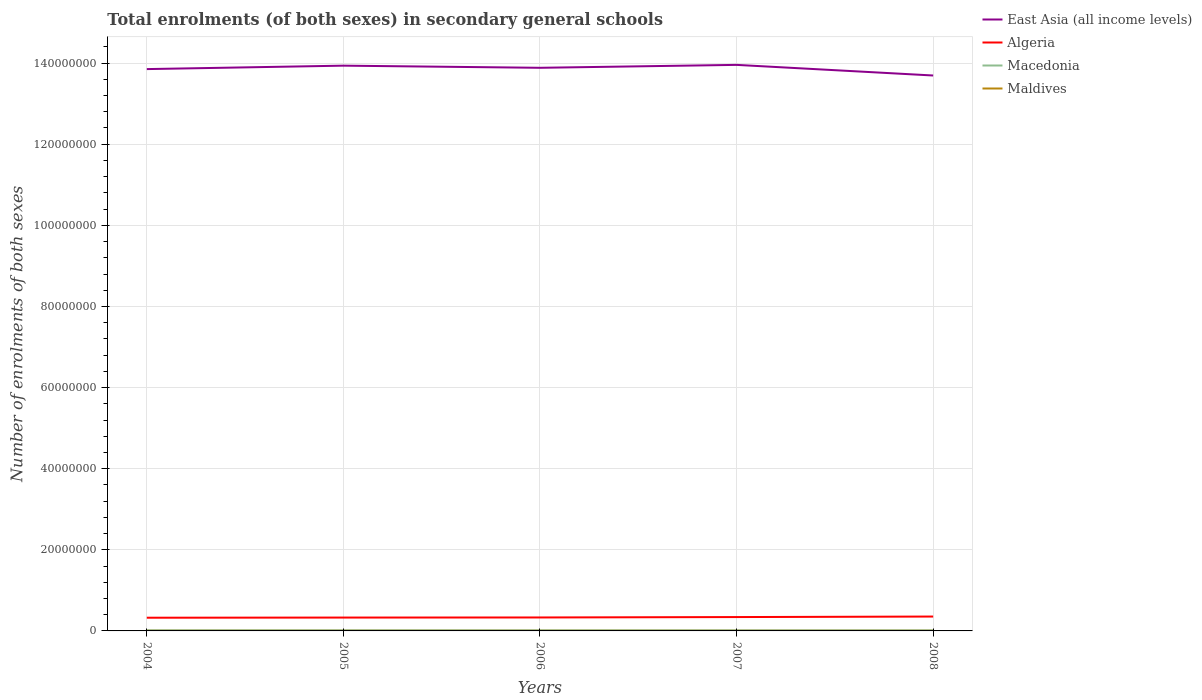Across all years, what is the maximum number of enrolments in secondary schools in Maldives?
Your answer should be very brief. 2.78e+04. In which year was the number of enrolments in secondary schools in East Asia (all income levels) maximum?
Offer a terse response. 2008. What is the total number of enrolments in secondary schools in Macedonia in the graph?
Offer a very short reply. 1554. What is the difference between the highest and the second highest number of enrolments in secondary schools in East Asia (all income levels)?
Your answer should be very brief. 2.62e+06. How many years are there in the graph?
Your answer should be compact. 5. What is the difference between two consecutive major ticks on the Y-axis?
Keep it short and to the point. 2.00e+07. Are the values on the major ticks of Y-axis written in scientific E-notation?
Ensure brevity in your answer.  No. Does the graph contain any zero values?
Provide a short and direct response. No. Where does the legend appear in the graph?
Ensure brevity in your answer.  Top right. How are the legend labels stacked?
Make the answer very short. Vertical. What is the title of the graph?
Give a very brief answer. Total enrolments (of both sexes) in secondary general schools. What is the label or title of the Y-axis?
Your answer should be compact. Number of enrolments of both sexes. What is the Number of enrolments of both sexes in East Asia (all income levels) in 2004?
Offer a very short reply. 1.39e+08. What is the Number of enrolments of both sexes in Algeria in 2004?
Provide a short and direct response. 3.25e+06. What is the Number of enrolments of both sexes of Macedonia in 2004?
Give a very brief answer. 1.58e+05. What is the Number of enrolments of both sexes of Maldives in 2004?
Your answer should be compact. 2.78e+04. What is the Number of enrolments of both sexes of East Asia (all income levels) in 2005?
Give a very brief answer. 1.39e+08. What is the Number of enrolments of both sexes of Algeria in 2005?
Make the answer very short. 3.29e+06. What is the Number of enrolments of both sexes in Macedonia in 2005?
Ensure brevity in your answer.  1.56e+05. What is the Number of enrolments of both sexes in Maldives in 2005?
Keep it short and to the point. 3.06e+04. What is the Number of enrolments of both sexes in East Asia (all income levels) in 2006?
Keep it short and to the point. 1.39e+08. What is the Number of enrolments of both sexes in Algeria in 2006?
Your answer should be compact. 3.32e+06. What is the Number of enrolments of both sexes of Macedonia in 2006?
Your answer should be compact. 1.55e+05. What is the Number of enrolments of both sexes of Maldives in 2006?
Your answer should be very brief. 3.13e+04. What is the Number of enrolments of both sexes in East Asia (all income levels) in 2007?
Provide a succinct answer. 1.40e+08. What is the Number of enrolments of both sexes in Algeria in 2007?
Your answer should be compact. 3.42e+06. What is the Number of enrolments of both sexes in Macedonia in 2007?
Ensure brevity in your answer.  1.50e+05. What is the Number of enrolments of both sexes in Maldives in 2007?
Your response must be concise. 3.19e+04. What is the Number of enrolments of both sexes of East Asia (all income levels) in 2008?
Your answer should be compact. 1.37e+08. What is the Number of enrolments of both sexes in Algeria in 2008?
Keep it short and to the point. 3.54e+06. What is the Number of enrolments of both sexes of Macedonia in 2008?
Give a very brief answer. 1.47e+05. What is the Number of enrolments of both sexes of Maldives in 2008?
Your answer should be very brief. 3.08e+04. Across all years, what is the maximum Number of enrolments of both sexes of East Asia (all income levels)?
Your answer should be compact. 1.40e+08. Across all years, what is the maximum Number of enrolments of both sexes in Algeria?
Your response must be concise. 3.54e+06. Across all years, what is the maximum Number of enrolments of both sexes of Macedonia?
Your answer should be very brief. 1.58e+05. Across all years, what is the maximum Number of enrolments of both sexes of Maldives?
Keep it short and to the point. 3.19e+04. Across all years, what is the minimum Number of enrolments of both sexes of East Asia (all income levels)?
Make the answer very short. 1.37e+08. Across all years, what is the minimum Number of enrolments of both sexes of Algeria?
Your answer should be compact. 3.25e+06. Across all years, what is the minimum Number of enrolments of both sexes in Macedonia?
Give a very brief answer. 1.47e+05. Across all years, what is the minimum Number of enrolments of both sexes in Maldives?
Your response must be concise. 2.78e+04. What is the total Number of enrolments of both sexes in East Asia (all income levels) in the graph?
Offer a very short reply. 6.93e+08. What is the total Number of enrolments of both sexes of Algeria in the graph?
Your answer should be very brief. 1.68e+07. What is the total Number of enrolments of both sexes of Macedonia in the graph?
Your answer should be compact. 7.66e+05. What is the total Number of enrolments of both sexes of Maldives in the graph?
Give a very brief answer. 1.52e+05. What is the difference between the Number of enrolments of both sexes in East Asia (all income levels) in 2004 and that in 2005?
Provide a succinct answer. -8.46e+05. What is the difference between the Number of enrolments of both sexes in Algeria in 2004 and that in 2005?
Offer a terse response. -3.72e+04. What is the difference between the Number of enrolments of both sexes in Macedonia in 2004 and that in 2005?
Keep it short and to the point. 1554. What is the difference between the Number of enrolments of both sexes of Maldives in 2004 and that in 2005?
Keep it short and to the point. -2825. What is the difference between the Number of enrolments of both sexes of East Asia (all income levels) in 2004 and that in 2006?
Your answer should be very brief. -3.21e+05. What is the difference between the Number of enrolments of both sexes of Algeria in 2004 and that in 2006?
Offer a very short reply. -6.09e+04. What is the difference between the Number of enrolments of both sexes in Macedonia in 2004 and that in 2006?
Offer a terse response. 2586. What is the difference between the Number of enrolments of both sexes in Maldives in 2004 and that in 2006?
Provide a short and direct response. -3535. What is the difference between the Number of enrolments of both sexes in East Asia (all income levels) in 2004 and that in 2007?
Give a very brief answer. -1.04e+06. What is the difference between the Number of enrolments of both sexes of Algeria in 2004 and that in 2007?
Your response must be concise. -1.63e+05. What is the difference between the Number of enrolments of both sexes in Macedonia in 2004 and that in 2007?
Keep it short and to the point. 7251. What is the difference between the Number of enrolments of both sexes of Maldives in 2004 and that in 2007?
Make the answer very short. -4140. What is the difference between the Number of enrolments of both sexes of East Asia (all income levels) in 2004 and that in 2008?
Your answer should be compact. 1.58e+06. What is the difference between the Number of enrolments of both sexes in Algeria in 2004 and that in 2008?
Ensure brevity in your answer.  -2.88e+05. What is the difference between the Number of enrolments of both sexes of Macedonia in 2004 and that in 2008?
Your answer should be very brief. 1.05e+04. What is the difference between the Number of enrolments of both sexes in Maldives in 2004 and that in 2008?
Ensure brevity in your answer.  -3052. What is the difference between the Number of enrolments of both sexes in East Asia (all income levels) in 2005 and that in 2006?
Provide a succinct answer. 5.24e+05. What is the difference between the Number of enrolments of both sexes in Algeria in 2005 and that in 2006?
Your response must be concise. -2.37e+04. What is the difference between the Number of enrolments of both sexes in Macedonia in 2005 and that in 2006?
Keep it short and to the point. 1032. What is the difference between the Number of enrolments of both sexes in Maldives in 2005 and that in 2006?
Offer a terse response. -710. What is the difference between the Number of enrolments of both sexes of East Asia (all income levels) in 2005 and that in 2007?
Your answer should be very brief. -1.95e+05. What is the difference between the Number of enrolments of both sexes of Algeria in 2005 and that in 2007?
Offer a terse response. -1.26e+05. What is the difference between the Number of enrolments of both sexes in Macedonia in 2005 and that in 2007?
Make the answer very short. 5697. What is the difference between the Number of enrolments of both sexes in Maldives in 2005 and that in 2007?
Keep it short and to the point. -1315. What is the difference between the Number of enrolments of both sexes of East Asia (all income levels) in 2005 and that in 2008?
Provide a short and direct response. 2.43e+06. What is the difference between the Number of enrolments of both sexes of Algeria in 2005 and that in 2008?
Make the answer very short. -2.51e+05. What is the difference between the Number of enrolments of both sexes in Macedonia in 2005 and that in 2008?
Your answer should be very brief. 8988. What is the difference between the Number of enrolments of both sexes in Maldives in 2005 and that in 2008?
Offer a terse response. -227. What is the difference between the Number of enrolments of both sexes of East Asia (all income levels) in 2006 and that in 2007?
Your answer should be compact. -7.19e+05. What is the difference between the Number of enrolments of both sexes of Algeria in 2006 and that in 2007?
Offer a very short reply. -1.02e+05. What is the difference between the Number of enrolments of both sexes of Macedonia in 2006 and that in 2007?
Ensure brevity in your answer.  4665. What is the difference between the Number of enrolments of both sexes of Maldives in 2006 and that in 2007?
Your answer should be very brief. -605. What is the difference between the Number of enrolments of both sexes of East Asia (all income levels) in 2006 and that in 2008?
Provide a short and direct response. 1.90e+06. What is the difference between the Number of enrolments of both sexes in Algeria in 2006 and that in 2008?
Your answer should be very brief. -2.27e+05. What is the difference between the Number of enrolments of both sexes in Macedonia in 2006 and that in 2008?
Offer a terse response. 7956. What is the difference between the Number of enrolments of both sexes in Maldives in 2006 and that in 2008?
Make the answer very short. 483. What is the difference between the Number of enrolments of both sexes of East Asia (all income levels) in 2007 and that in 2008?
Your answer should be compact. 2.62e+06. What is the difference between the Number of enrolments of both sexes in Algeria in 2007 and that in 2008?
Offer a terse response. -1.25e+05. What is the difference between the Number of enrolments of both sexes of Macedonia in 2007 and that in 2008?
Your response must be concise. 3291. What is the difference between the Number of enrolments of both sexes of Maldives in 2007 and that in 2008?
Your answer should be very brief. 1088. What is the difference between the Number of enrolments of both sexes in East Asia (all income levels) in 2004 and the Number of enrolments of both sexes in Algeria in 2005?
Offer a terse response. 1.35e+08. What is the difference between the Number of enrolments of both sexes in East Asia (all income levels) in 2004 and the Number of enrolments of both sexes in Macedonia in 2005?
Provide a short and direct response. 1.38e+08. What is the difference between the Number of enrolments of both sexes of East Asia (all income levels) in 2004 and the Number of enrolments of both sexes of Maldives in 2005?
Ensure brevity in your answer.  1.38e+08. What is the difference between the Number of enrolments of both sexes in Algeria in 2004 and the Number of enrolments of both sexes in Macedonia in 2005?
Give a very brief answer. 3.10e+06. What is the difference between the Number of enrolments of both sexes in Algeria in 2004 and the Number of enrolments of both sexes in Maldives in 2005?
Your response must be concise. 3.22e+06. What is the difference between the Number of enrolments of both sexes in Macedonia in 2004 and the Number of enrolments of both sexes in Maldives in 2005?
Your answer should be very brief. 1.27e+05. What is the difference between the Number of enrolments of both sexes in East Asia (all income levels) in 2004 and the Number of enrolments of both sexes in Algeria in 2006?
Ensure brevity in your answer.  1.35e+08. What is the difference between the Number of enrolments of both sexes in East Asia (all income levels) in 2004 and the Number of enrolments of both sexes in Macedonia in 2006?
Your answer should be very brief. 1.38e+08. What is the difference between the Number of enrolments of both sexes of East Asia (all income levels) in 2004 and the Number of enrolments of both sexes of Maldives in 2006?
Offer a very short reply. 1.38e+08. What is the difference between the Number of enrolments of both sexes in Algeria in 2004 and the Number of enrolments of both sexes in Macedonia in 2006?
Make the answer very short. 3.10e+06. What is the difference between the Number of enrolments of both sexes in Algeria in 2004 and the Number of enrolments of both sexes in Maldives in 2006?
Keep it short and to the point. 3.22e+06. What is the difference between the Number of enrolments of both sexes in Macedonia in 2004 and the Number of enrolments of both sexes in Maldives in 2006?
Offer a very short reply. 1.26e+05. What is the difference between the Number of enrolments of both sexes in East Asia (all income levels) in 2004 and the Number of enrolments of both sexes in Algeria in 2007?
Keep it short and to the point. 1.35e+08. What is the difference between the Number of enrolments of both sexes in East Asia (all income levels) in 2004 and the Number of enrolments of both sexes in Macedonia in 2007?
Provide a short and direct response. 1.38e+08. What is the difference between the Number of enrolments of both sexes of East Asia (all income levels) in 2004 and the Number of enrolments of both sexes of Maldives in 2007?
Your answer should be compact. 1.38e+08. What is the difference between the Number of enrolments of both sexes in Algeria in 2004 and the Number of enrolments of both sexes in Macedonia in 2007?
Provide a succinct answer. 3.10e+06. What is the difference between the Number of enrolments of both sexes in Algeria in 2004 and the Number of enrolments of both sexes in Maldives in 2007?
Offer a very short reply. 3.22e+06. What is the difference between the Number of enrolments of both sexes in Macedonia in 2004 and the Number of enrolments of both sexes in Maldives in 2007?
Give a very brief answer. 1.26e+05. What is the difference between the Number of enrolments of both sexes in East Asia (all income levels) in 2004 and the Number of enrolments of both sexes in Algeria in 2008?
Your answer should be very brief. 1.35e+08. What is the difference between the Number of enrolments of both sexes in East Asia (all income levels) in 2004 and the Number of enrolments of both sexes in Macedonia in 2008?
Make the answer very short. 1.38e+08. What is the difference between the Number of enrolments of both sexes in East Asia (all income levels) in 2004 and the Number of enrolments of both sexes in Maldives in 2008?
Your response must be concise. 1.38e+08. What is the difference between the Number of enrolments of both sexes of Algeria in 2004 and the Number of enrolments of both sexes of Macedonia in 2008?
Offer a very short reply. 3.11e+06. What is the difference between the Number of enrolments of both sexes of Algeria in 2004 and the Number of enrolments of both sexes of Maldives in 2008?
Your answer should be very brief. 3.22e+06. What is the difference between the Number of enrolments of both sexes of Macedonia in 2004 and the Number of enrolments of both sexes of Maldives in 2008?
Ensure brevity in your answer.  1.27e+05. What is the difference between the Number of enrolments of both sexes in East Asia (all income levels) in 2005 and the Number of enrolments of both sexes in Algeria in 2006?
Your answer should be very brief. 1.36e+08. What is the difference between the Number of enrolments of both sexes of East Asia (all income levels) in 2005 and the Number of enrolments of both sexes of Macedonia in 2006?
Ensure brevity in your answer.  1.39e+08. What is the difference between the Number of enrolments of both sexes in East Asia (all income levels) in 2005 and the Number of enrolments of both sexes in Maldives in 2006?
Your response must be concise. 1.39e+08. What is the difference between the Number of enrolments of both sexes in Algeria in 2005 and the Number of enrolments of both sexes in Macedonia in 2006?
Ensure brevity in your answer.  3.14e+06. What is the difference between the Number of enrolments of both sexes in Algeria in 2005 and the Number of enrolments of both sexes in Maldives in 2006?
Provide a succinct answer. 3.26e+06. What is the difference between the Number of enrolments of both sexes of Macedonia in 2005 and the Number of enrolments of both sexes of Maldives in 2006?
Ensure brevity in your answer.  1.25e+05. What is the difference between the Number of enrolments of both sexes in East Asia (all income levels) in 2005 and the Number of enrolments of both sexes in Algeria in 2007?
Offer a terse response. 1.36e+08. What is the difference between the Number of enrolments of both sexes in East Asia (all income levels) in 2005 and the Number of enrolments of both sexes in Macedonia in 2007?
Offer a terse response. 1.39e+08. What is the difference between the Number of enrolments of both sexes in East Asia (all income levels) in 2005 and the Number of enrolments of both sexes in Maldives in 2007?
Your response must be concise. 1.39e+08. What is the difference between the Number of enrolments of both sexes in Algeria in 2005 and the Number of enrolments of both sexes in Macedonia in 2007?
Your answer should be compact. 3.14e+06. What is the difference between the Number of enrolments of both sexes in Algeria in 2005 and the Number of enrolments of both sexes in Maldives in 2007?
Offer a very short reply. 3.26e+06. What is the difference between the Number of enrolments of both sexes in Macedonia in 2005 and the Number of enrolments of both sexes in Maldives in 2007?
Offer a terse response. 1.24e+05. What is the difference between the Number of enrolments of both sexes of East Asia (all income levels) in 2005 and the Number of enrolments of both sexes of Algeria in 2008?
Provide a succinct answer. 1.36e+08. What is the difference between the Number of enrolments of both sexes in East Asia (all income levels) in 2005 and the Number of enrolments of both sexes in Macedonia in 2008?
Offer a very short reply. 1.39e+08. What is the difference between the Number of enrolments of both sexes in East Asia (all income levels) in 2005 and the Number of enrolments of both sexes in Maldives in 2008?
Give a very brief answer. 1.39e+08. What is the difference between the Number of enrolments of both sexes in Algeria in 2005 and the Number of enrolments of both sexes in Macedonia in 2008?
Provide a short and direct response. 3.15e+06. What is the difference between the Number of enrolments of both sexes in Algeria in 2005 and the Number of enrolments of both sexes in Maldives in 2008?
Offer a very short reply. 3.26e+06. What is the difference between the Number of enrolments of both sexes of Macedonia in 2005 and the Number of enrolments of both sexes of Maldives in 2008?
Provide a succinct answer. 1.25e+05. What is the difference between the Number of enrolments of both sexes of East Asia (all income levels) in 2006 and the Number of enrolments of both sexes of Algeria in 2007?
Ensure brevity in your answer.  1.35e+08. What is the difference between the Number of enrolments of both sexes of East Asia (all income levels) in 2006 and the Number of enrolments of both sexes of Macedonia in 2007?
Offer a very short reply. 1.39e+08. What is the difference between the Number of enrolments of both sexes of East Asia (all income levels) in 2006 and the Number of enrolments of both sexes of Maldives in 2007?
Ensure brevity in your answer.  1.39e+08. What is the difference between the Number of enrolments of both sexes of Algeria in 2006 and the Number of enrolments of both sexes of Macedonia in 2007?
Your answer should be very brief. 3.17e+06. What is the difference between the Number of enrolments of both sexes of Algeria in 2006 and the Number of enrolments of both sexes of Maldives in 2007?
Your answer should be very brief. 3.28e+06. What is the difference between the Number of enrolments of both sexes in Macedonia in 2006 and the Number of enrolments of both sexes in Maldives in 2007?
Offer a terse response. 1.23e+05. What is the difference between the Number of enrolments of both sexes of East Asia (all income levels) in 2006 and the Number of enrolments of both sexes of Algeria in 2008?
Make the answer very short. 1.35e+08. What is the difference between the Number of enrolments of both sexes in East Asia (all income levels) in 2006 and the Number of enrolments of both sexes in Macedonia in 2008?
Offer a terse response. 1.39e+08. What is the difference between the Number of enrolments of both sexes in East Asia (all income levels) in 2006 and the Number of enrolments of both sexes in Maldives in 2008?
Your answer should be very brief. 1.39e+08. What is the difference between the Number of enrolments of both sexes of Algeria in 2006 and the Number of enrolments of both sexes of Macedonia in 2008?
Your answer should be very brief. 3.17e+06. What is the difference between the Number of enrolments of both sexes in Algeria in 2006 and the Number of enrolments of both sexes in Maldives in 2008?
Ensure brevity in your answer.  3.28e+06. What is the difference between the Number of enrolments of both sexes in Macedonia in 2006 and the Number of enrolments of both sexes in Maldives in 2008?
Your answer should be very brief. 1.24e+05. What is the difference between the Number of enrolments of both sexes of East Asia (all income levels) in 2007 and the Number of enrolments of both sexes of Algeria in 2008?
Ensure brevity in your answer.  1.36e+08. What is the difference between the Number of enrolments of both sexes in East Asia (all income levels) in 2007 and the Number of enrolments of both sexes in Macedonia in 2008?
Provide a succinct answer. 1.39e+08. What is the difference between the Number of enrolments of both sexes in East Asia (all income levels) in 2007 and the Number of enrolments of both sexes in Maldives in 2008?
Make the answer very short. 1.40e+08. What is the difference between the Number of enrolments of both sexes in Algeria in 2007 and the Number of enrolments of both sexes in Macedonia in 2008?
Your answer should be very brief. 3.27e+06. What is the difference between the Number of enrolments of both sexes in Algeria in 2007 and the Number of enrolments of both sexes in Maldives in 2008?
Your answer should be compact. 3.39e+06. What is the difference between the Number of enrolments of both sexes of Macedonia in 2007 and the Number of enrolments of both sexes of Maldives in 2008?
Ensure brevity in your answer.  1.19e+05. What is the average Number of enrolments of both sexes of East Asia (all income levels) per year?
Ensure brevity in your answer.  1.39e+08. What is the average Number of enrolments of both sexes of Algeria per year?
Provide a succinct answer. 3.36e+06. What is the average Number of enrolments of both sexes of Macedonia per year?
Provide a short and direct response. 1.53e+05. What is the average Number of enrolments of both sexes in Maldives per year?
Make the answer very short. 3.05e+04. In the year 2004, what is the difference between the Number of enrolments of both sexes of East Asia (all income levels) and Number of enrolments of both sexes of Algeria?
Keep it short and to the point. 1.35e+08. In the year 2004, what is the difference between the Number of enrolments of both sexes of East Asia (all income levels) and Number of enrolments of both sexes of Macedonia?
Keep it short and to the point. 1.38e+08. In the year 2004, what is the difference between the Number of enrolments of both sexes of East Asia (all income levels) and Number of enrolments of both sexes of Maldives?
Make the answer very short. 1.38e+08. In the year 2004, what is the difference between the Number of enrolments of both sexes in Algeria and Number of enrolments of both sexes in Macedonia?
Provide a succinct answer. 3.10e+06. In the year 2004, what is the difference between the Number of enrolments of both sexes of Algeria and Number of enrolments of both sexes of Maldives?
Your answer should be compact. 3.23e+06. In the year 2004, what is the difference between the Number of enrolments of both sexes of Macedonia and Number of enrolments of both sexes of Maldives?
Give a very brief answer. 1.30e+05. In the year 2005, what is the difference between the Number of enrolments of both sexes in East Asia (all income levels) and Number of enrolments of both sexes in Algeria?
Offer a very short reply. 1.36e+08. In the year 2005, what is the difference between the Number of enrolments of both sexes of East Asia (all income levels) and Number of enrolments of both sexes of Macedonia?
Your answer should be very brief. 1.39e+08. In the year 2005, what is the difference between the Number of enrolments of both sexes in East Asia (all income levels) and Number of enrolments of both sexes in Maldives?
Make the answer very short. 1.39e+08. In the year 2005, what is the difference between the Number of enrolments of both sexes of Algeria and Number of enrolments of both sexes of Macedonia?
Offer a very short reply. 3.14e+06. In the year 2005, what is the difference between the Number of enrolments of both sexes in Algeria and Number of enrolments of both sexes in Maldives?
Offer a terse response. 3.26e+06. In the year 2005, what is the difference between the Number of enrolments of both sexes in Macedonia and Number of enrolments of both sexes in Maldives?
Offer a terse response. 1.25e+05. In the year 2006, what is the difference between the Number of enrolments of both sexes in East Asia (all income levels) and Number of enrolments of both sexes in Algeria?
Offer a terse response. 1.36e+08. In the year 2006, what is the difference between the Number of enrolments of both sexes in East Asia (all income levels) and Number of enrolments of both sexes in Macedonia?
Your response must be concise. 1.39e+08. In the year 2006, what is the difference between the Number of enrolments of both sexes of East Asia (all income levels) and Number of enrolments of both sexes of Maldives?
Your answer should be compact. 1.39e+08. In the year 2006, what is the difference between the Number of enrolments of both sexes in Algeria and Number of enrolments of both sexes in Macedonia?
Offer a very short reply. 3.16e+06. In the year 2006, what is the difference between the Number of enrolments of both sexes in Algeria and Number of enrolments of both sexes in Maldives?
Keep it short and to the point. 3.28e+06. In the year 2006, what is the difference between the Number of enrolments of both sexes of Macedonia and Number of enrolments of both sexes of Maldives?
Offer a terse response. 1.24e+05. In the year 2007, what is the difference between the Number of enrolments of both sexes in East Asia (all income levels) and Number of enrolments of both sexes in Algeria?
Provide a short and direct response. 1.36e+08. In the year 2007, what is the difference between the Number of enrolments of both sexes of East Asia (all income levels) and Number of enrolments of both sexes of Macedonia?
Ensure brevity in your answer.  1.39e+08. In the year 2007, what is the difference between the Number of enrolments of both sexes in East Asia (all income levels) and Number of enrolments of both sexes in Maldives?
Offer a very short reply. 1.40e+08. In the year 2007, what is the difference between the Number of enrolments of both sexes of Algeria and Number of enrolments of both sexes of Macedonia?
Your response must be concise. 3.27e+06. In the year 2007, what is the difference between the Number of enrolments of both sexes of Algeria and Number of enrolments of both sexes of Maldives?
Your answer should be compact. 3.39e+06. In the year 2007, what is the difference between the Number of enrolments of both sexes in Macedonia and Number of enrolments of both sexes in Maldives?
Ensure brevity in your answer.  1.18e+05. In the year 2008, what is the difference between the Number of enrolments of both sexes of East Asia (all income levels) and Number of enrolments of both sexes of Algeria?
Provide a succinct answer. 1.33e+08. In the year 2008, what is the difference between the Number of enrolments of both sexes in East Asia (all income levels) and Number of enrolments of both sexes in Macedonia?
Ensure brevity in your answer.  1.37e+08. In the year 2008, what is the difference between the Number of enrolments of both sexes of East Asia (all income levels) and Number of enrolments of both sexes of Maldives?
Ensure brevity in your answer.  1.37e+08. In the year 2008, what is the difference between the Number of enrolments of both sexes in Algeria and Number of enrolments of both sexes in Macedonia?
Your answer should be compact. 3.40e+06. In the year 2008, what is the difference between the Number of enrolments of both sexes in Algeria and Number of enrolments of both sexes in Maldives?
Provide a succinct answer. 3.51e+06. In the year 2008, what is the difference between the Number of enrolments of both sexes in Macedonia and Number of enrolments of both sexes in Maldives?
Provide a short and direct response. 1.16e+05. What is the ratio of the Number of enrolments of both sexes in Algeria in 2004 to that in 2005?
Provide a succinct answer. 0.99. What is the ratio of the Number of enrolments of both sexes of Maldives in 2004 to that in 2005?
Make the answer very short. 0.91. What is the ratio of the Number of enrolments of both sexes of East Asia (all income levels) in 2004 to that in 2006?
Make the answer very short. 1. What is the ratio of the Number of enrolments of both sexes of Algeria in 2004 to that in 2006?
Offer a very short reply. 0.98. What is the ratio of the Number of enrolments of both sexes in Macedonia in 2004 to that in 2006?
Your response must be concise. 1.02. What is the ratio of the Number of enrolments of both sexes in Maldives in 2004 to that in 2006?
Provide a succinct answer. 0.89. What is the ratio of the Number of enrolments of both sexes in East Asia (all income levels) in 2004 to that in 2007?
Provide a succinct answer. 0.99. What is the ratio of the Number of enrolments of both sexes in Algeria in 2004 to that in 2007?
Your response must be concise. 0.95. What is the ratio of the Number of enrolments of both sexes in Macedonia in 2004 to that in 2007?
Offer a very short reply. 1.05. What is the ratio of the Number of enrolments of both sexes of Maldives in 2004 to that in 2007?
Offer a very short reply. 0.87. What is the ratio of the Number of enrolments of both sexes of East Asia (all income levels) in 2004 to that in 2008?
Offer a very short reply. 1.01. What is the ratio of the Number of enrolments of both sexes of Algeria in 2004 to that in 2008?
Ensure brevity in your answer.  0.92. What is the ratio of the Number of enrolments of both sexes of Macedonia in 2004 to that in 2008?
Offer a very short reply. 1.07. What is the ratio of the Number of enrolments of both sexes in Maldives in 2004 to that in 2008?
Provide a short and direct response. 0.9. What is the ratio of the Number of enrolments of both sexes of Algeria in 2005 to that in 2006?
Offer a very short reply. 0.99. What is the ratio of the Number of enrolments of both sexes of Macedonia in 2005 to that in 2006?
Give a very brief answer. 1.01. What is the ratio of the Number of enrolments of both sexes in Maldives in 2005 to that in 2006?
Keep it short and to the point. 0.98. What is the ratio of the Number of enrolments of both sexes of East Asia (all income levels) in 2005 to that in 2007?
Keep it short and to the point. 1. What is the ratio of the Number of enrolments of both sexes of Algeria in 2005 to that in 2007?
Provide a succinct answer. 0.96. What is the ratio of the Number of enrolments of both sexes of Macedonia in 2005 to that in 2007?
Keep it short and to the point. 1.04. What is the ratio of the Number of enrolments of both sexes of Maldives in 2005 to that in 2007?
Give a very brief answer. 0.96. What is the ratio of the Number of enrolments of both sexes in East Asia (all income levels) in 2005 to that in 2008?
Offer a terse response. 1.02. What is the ratio of the Number of enrolments of both sexes of Algeria in 2005 to that in 2008?
Your response must be concise. 0.93. What is the ratio of the Number of enrolments of both sexes in Macedonia in 2005 to that in 2008?
Your response must be concise. 1.06. What is the ratio of the Number of enrolments of both sexes in East Asia (all income levels) in 2006 to that in 2007?
Give a very brief answer. 0.99. What is the ratio of the Number of enrolments of both sexes in Algeria in 2006 to that in 2007?
Offer a terse response. 0.97. What is the ratio of the Number of enrolments of both sexes in Macedonia in 2006 to that in 2007?
Provide a short and direct response. 1.03. What is the ratio of the Number of enrolments of both sexes of Maldives in 2006 to that in 2007?
Provide a succinct answer. 0.98. What is the ratio of the Number of enrolments of both sexes of East Asia (all income levels) in 2006 to that in 2008?
Offer a terse response. 1.01. What is the ratio of the Number of enrolments of both sexes of Algeria in 2006 to that in 2008?
Keep it short and to the point. 0.94. What is the ratio of the Number of enrolments of both sexes in Macedonia in 2006 to that in 2008?
Your answer should be very brief. 1.05. What is the ratio of the Number of enrolments of both sexes in Maldives in 2006 to that in 2008?
Offer a terse response. 1.02. What is the ratio of the Number of enrolments of both sexes of East Asia (all income levels) in 2007 to that in 2008?
Provide a short and direct response. 1.02. What is the ratio of the Number of enrolments of both sexes in Algeria in 2007 to that in 2008?
Keep it short and to the point. 0.96. What is the ratio of the Number of enrolments of both sexes of Macedonia in 2007 to that in 2008?
Offer a terse response. 1.02. What is the ratio of the Number of enrolments of both sexes in Maldives in 2007 to that in 2008?
Ensure brevity in your answer.  1.04. What is the difference between the highest and the second highest Number of enrolments of both sexes of East Asia (all income levels)?
Your answer should be very brief. 1.95e+05. What is the difference between the highest and the second highest Number of enrolments of both sexes of Algeria?
Make the answer very short. 1.25e+05. What is the difference between the highest and the second highest Number of enrolments of both sexes of Macedonia?
Provide a short and direct response. 1554. What is the difference between the highest and the second highest Number of enrolments of both sexes of Maldives?
Provide a short and direct response. 605. What is the difference between the highest and the lowest Number of enrolments of both sexes of East Asia (all income levels)?
Provide a succinct answer. 2.62e+06. What is the difference between the highest and the lowest Number of enrolments of both sexes in Algeria?
Your answer should be compact. 2.88e+05. What is the difference between the highest and the lowest Number of enrolments of both sexes of Macedonia?
Make the answer very short. 1.05e+04. What is the difference between the highest and the lowest Number of enrolments of both sexes of Maldives?
Offer a very short reply. 4140. 